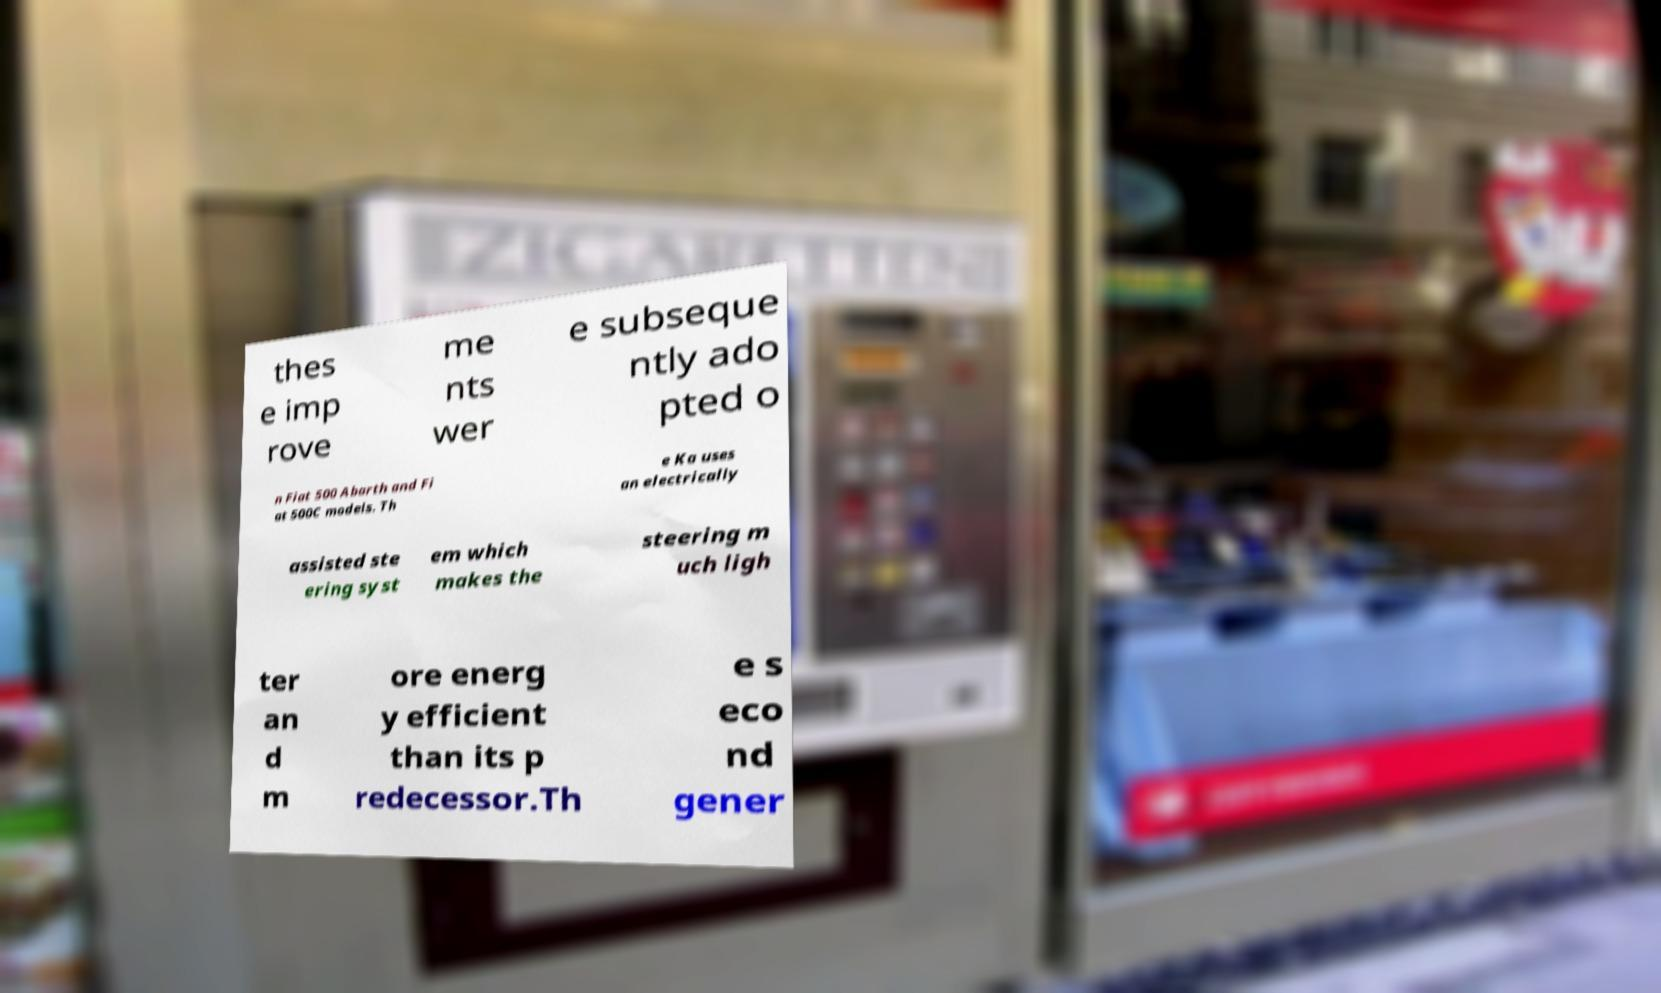Could you assist in decoding the text presented in this image and type it out clearly? thes e imp rove me nts wer e subseque ntly ado pted o n Fiat 500 Abarth and Fi at 500C models. Th e Ka uses an electrically assisted ste ering syst em which makes the steering m uch ligh ter an d m ore energ y efficient than its p redecessor.Th e s eco nd gener 